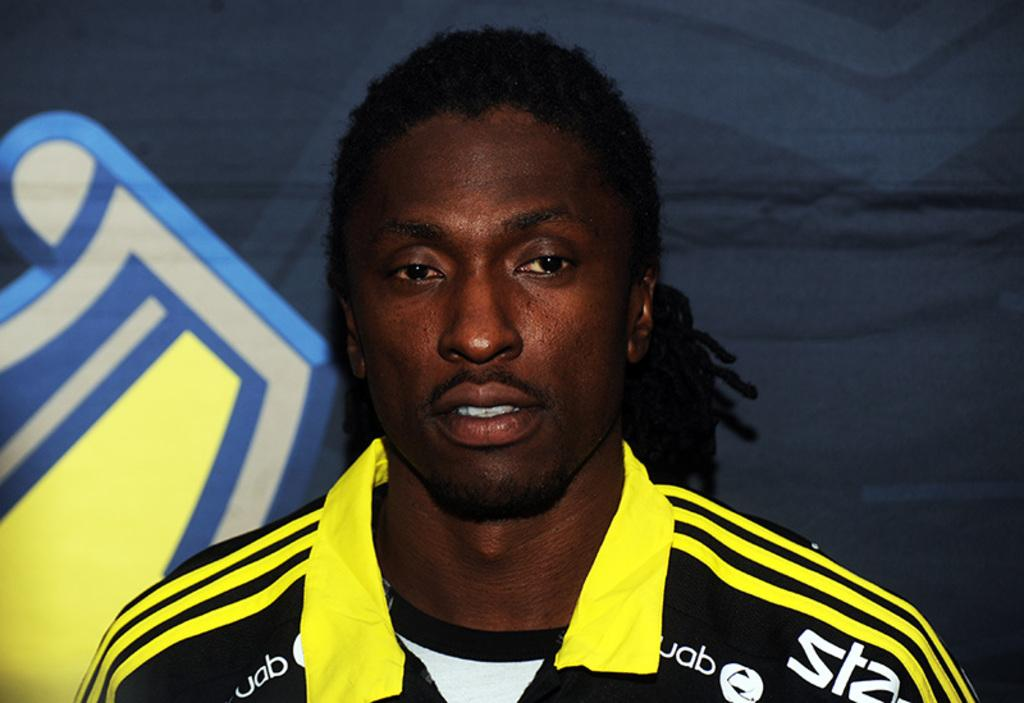What is the main subject in the foreground of the image? There is a man in the foreground of the image. What is the man wearing in the image? The man is wearing a yellow and black shirt. Are there any specific details about the shirt? Yes, there is text on the shirt. What can be seen in the background of the image? There is a board in the background of the image. How does the man maintain his balance while standing on the building in the image? There is no building present in the image, and the man is not shown balancing on any structure. 